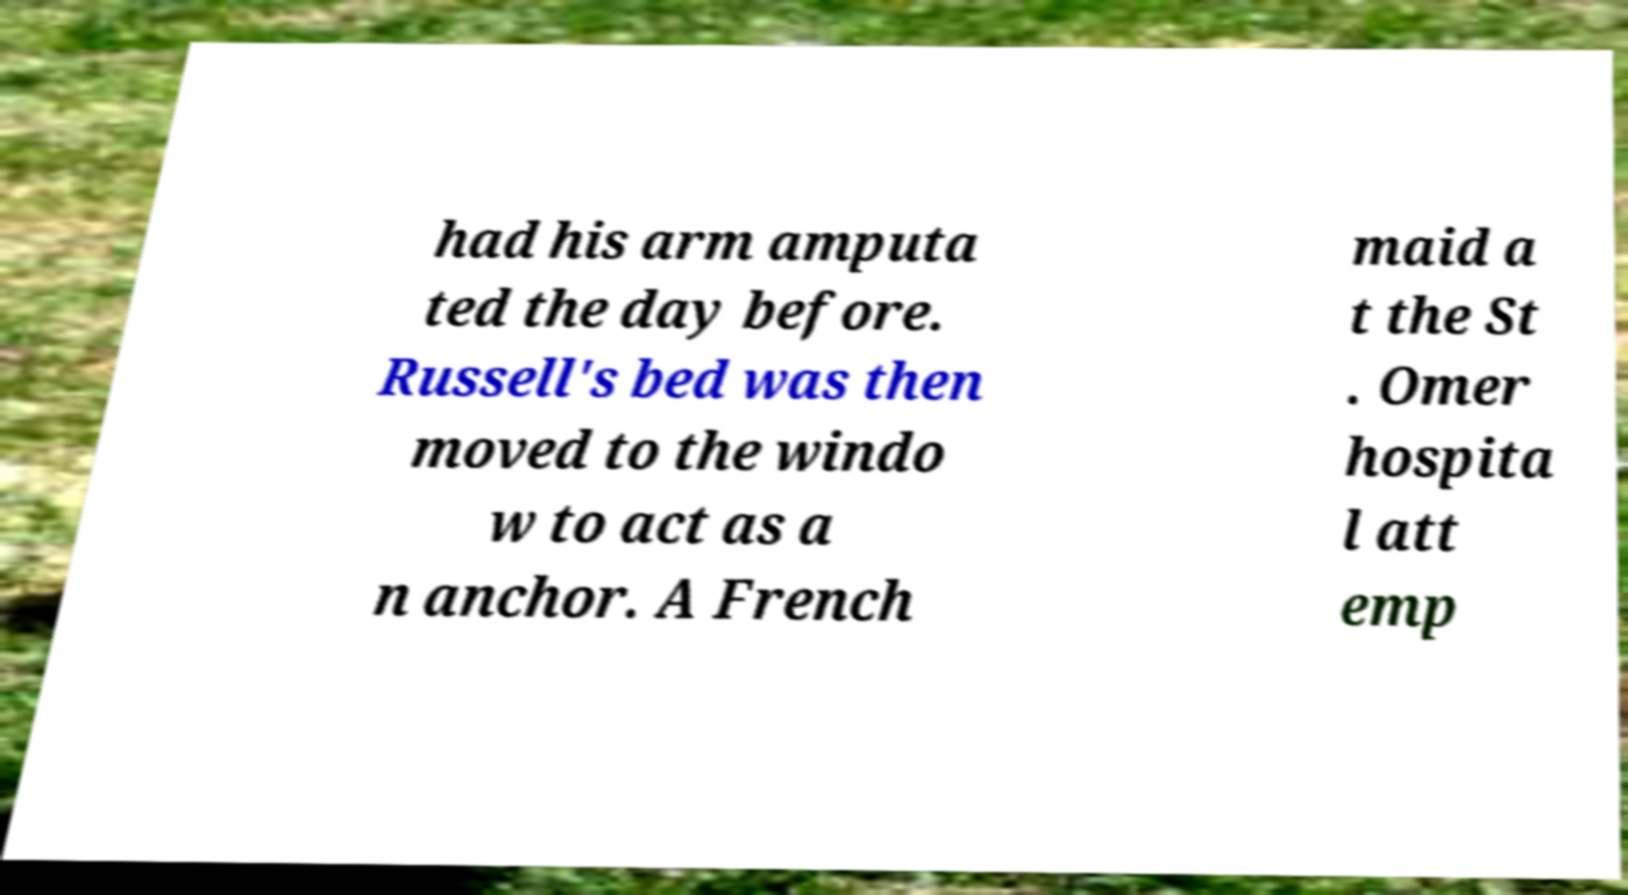I need the written content from this picture converted into text. Can you do that? had his arm amputa ted the day before. Russell's bed was then moved to the windo w to act as a n anchor. A French maid a t the St . Omer hospita l att emp 